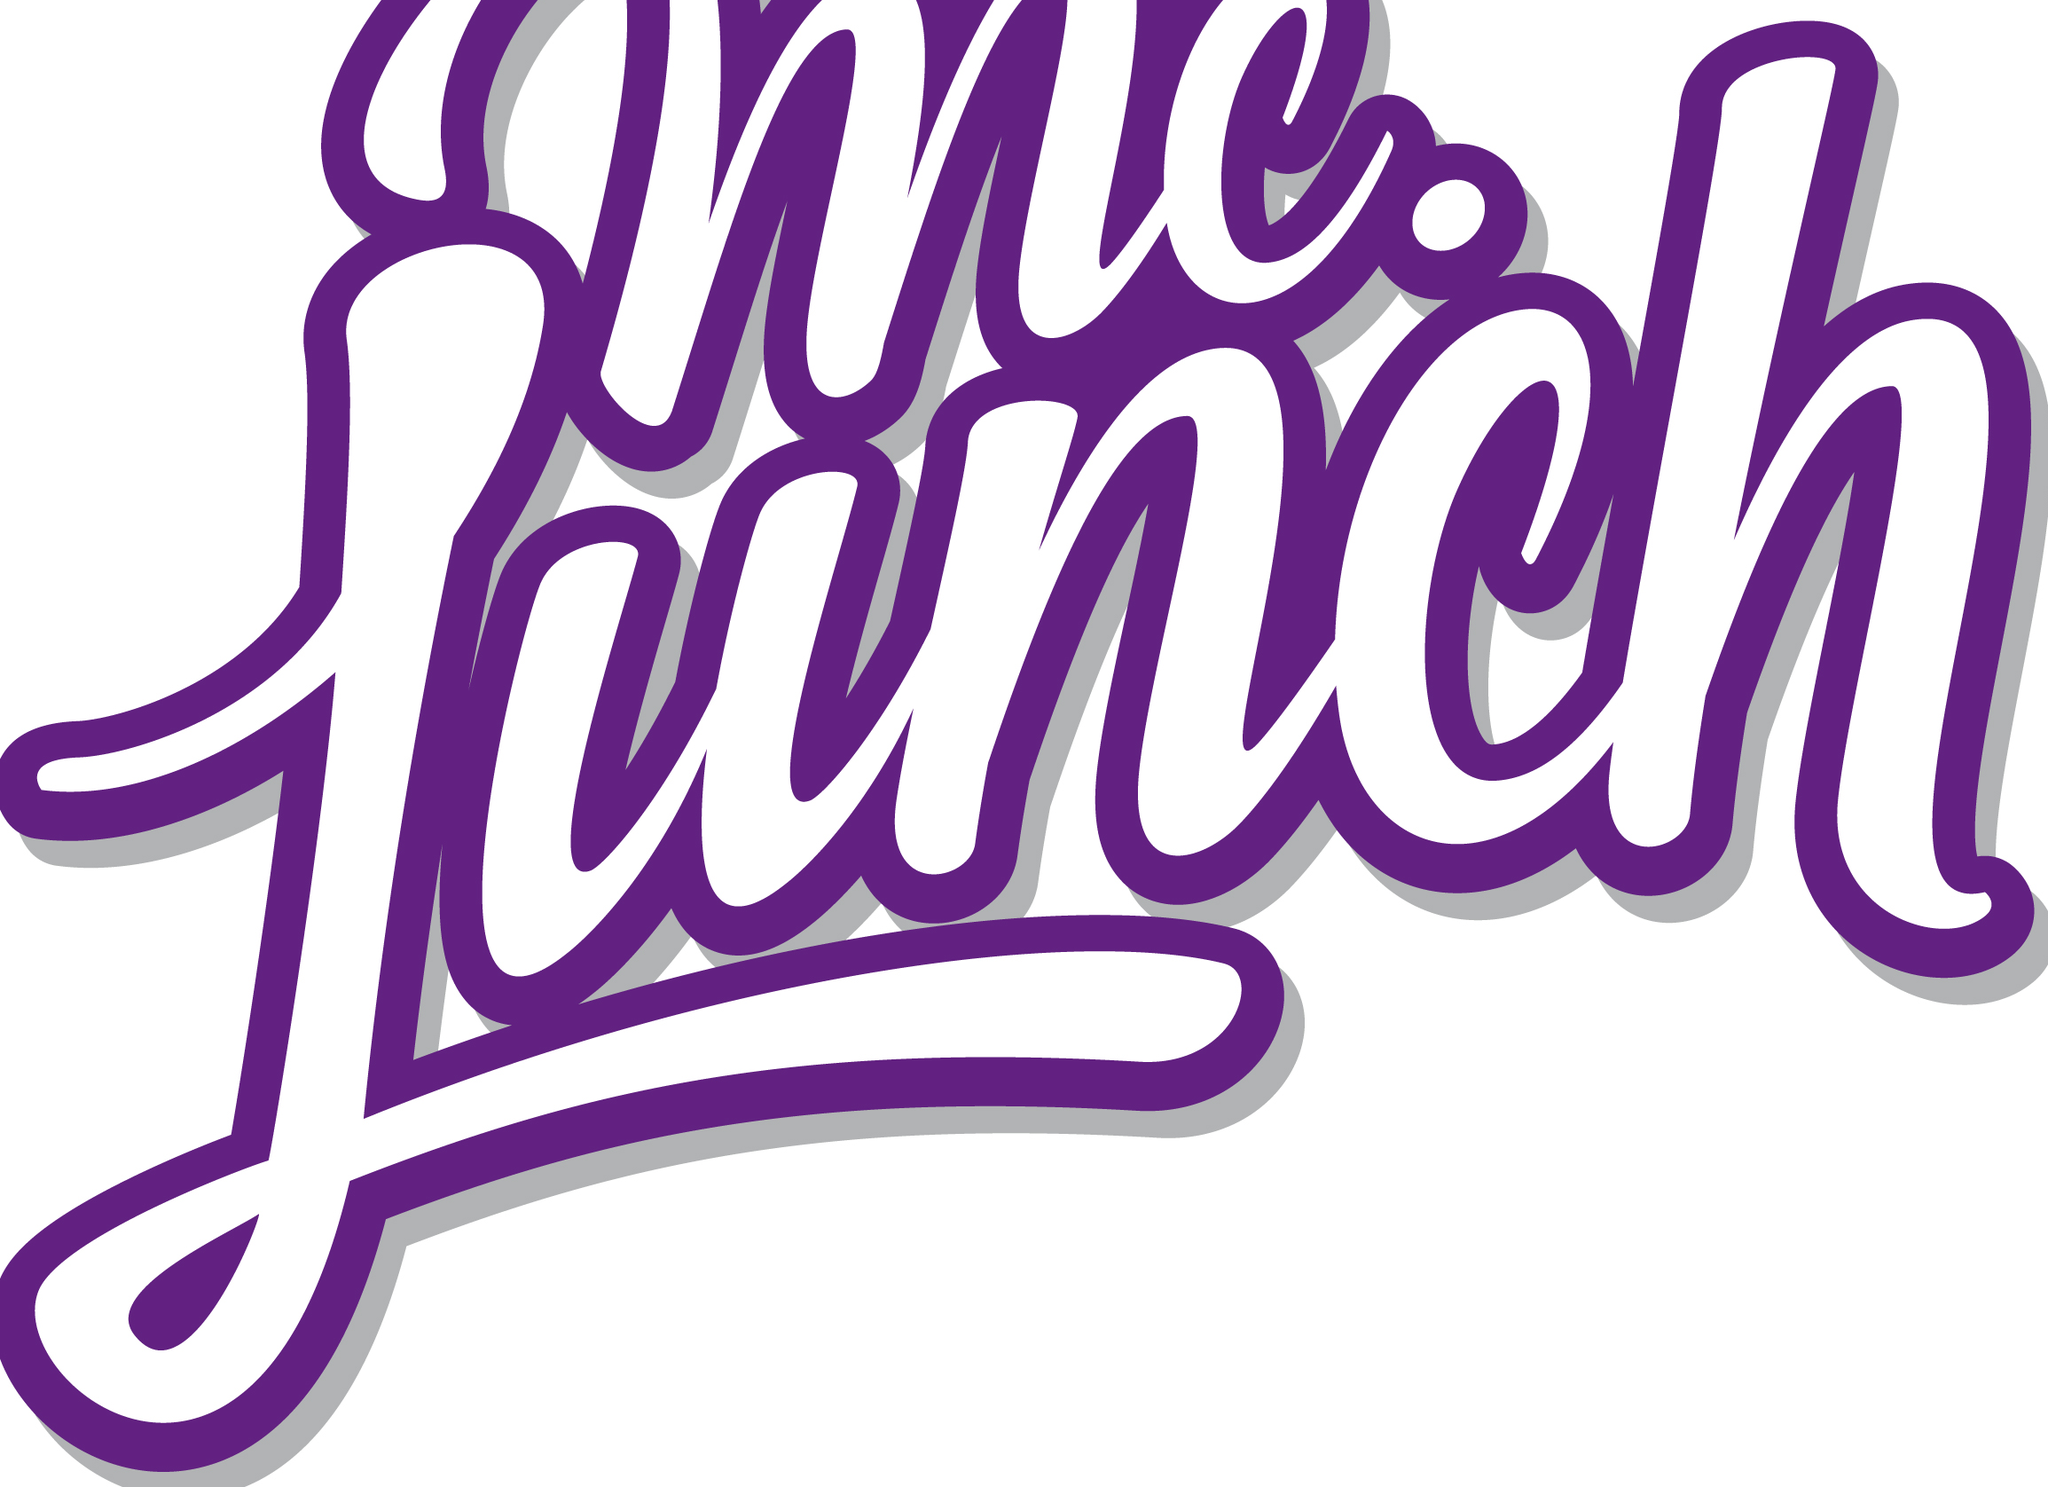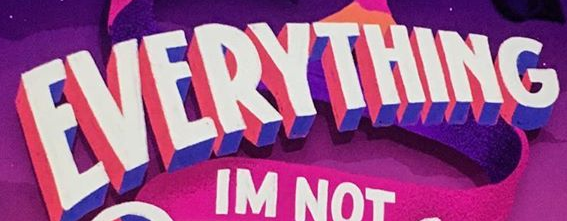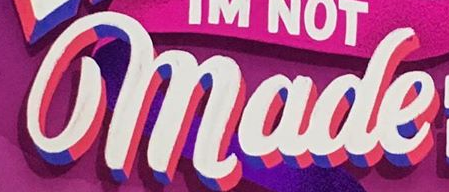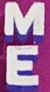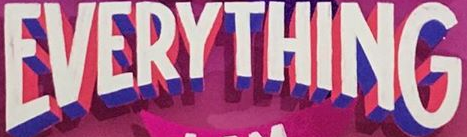What text is displayed in these images sequentially, separated by a semicolon? Lunch; EVERYTHING; made; ME; EVERYTHING 